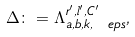<formula> <loc_0><loc_0><loc_500><loc_500>\Delta \colon = \Lambda _ { a , b , k , \ e p s } ^ { r ^ { \prime } , l ^ { \prime } , C ^ { \prime } } ,</formula> 